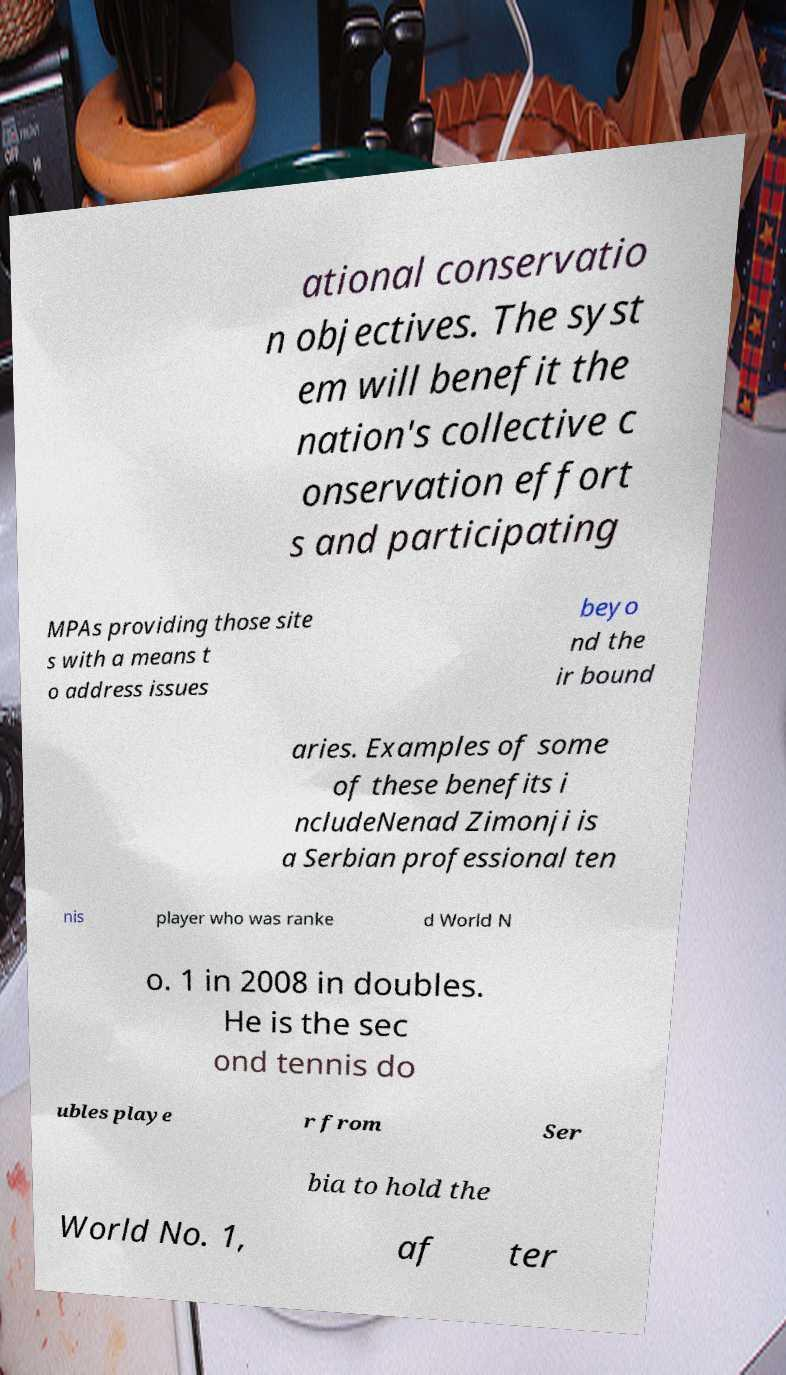Please identify and transcribe the text found in this image. ational conservatio n objectives. The syst em will benefit the nation's collective c onservation effort s and participating MPAs providing those site s with a means t o address issues beyo nd the ir bound aries. Examples of some of these benefits i ncludeNenad Zimonji is a Serbian professional ten nis player who was ranke d World N o. 1 in 2008 in doubles. He is the sec ond tennis do ubles playe r from Ser bia to hold the World No. 1, af ter 